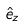<formula> <loc_0><loc_0><loc_500><loc_500>\hat { e } _ { z }</formula> 